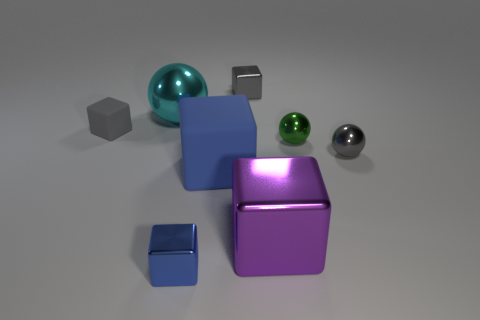There is another small matte object that is the same shape as the small blue thing; what is its color?
Keep it short and to the point. Gray. How many balls are the same color as the small matte block?
Your answer should be compact. 1. There is a metal block that is behind the big cyan ball; are there any big purple shiny objects behind it?
Make the answer very short. No. How many shiny blocks are right of the big blue matte object and in front of the large purple cube?
Make the answer very short. 0. What number of cyan balls have the same material as the small green object?
Offer a terse response. 1. What is the size of the rubber object on the left side of the tiny metal block left of the small gray metal block?
Your answer should be very brief. Small. Are there any other large blue objects of the same shape as the blue metallic thing?
Provide a short and direct response. Yes. There is a metal object on the left side of the small blue object; is its size the same as the block that is left of the tiny blue cube?
Offer a very short reply. No. Are there fewer big metal things that are on the left side of the blue rubber cube than metallic balls that are in front of the cyan metallic thing?
Make the answer very short. Yes. There is a small metal thing that is in front of the purple shiny cube; what color is it?
Offer a very short reply. Blue. 